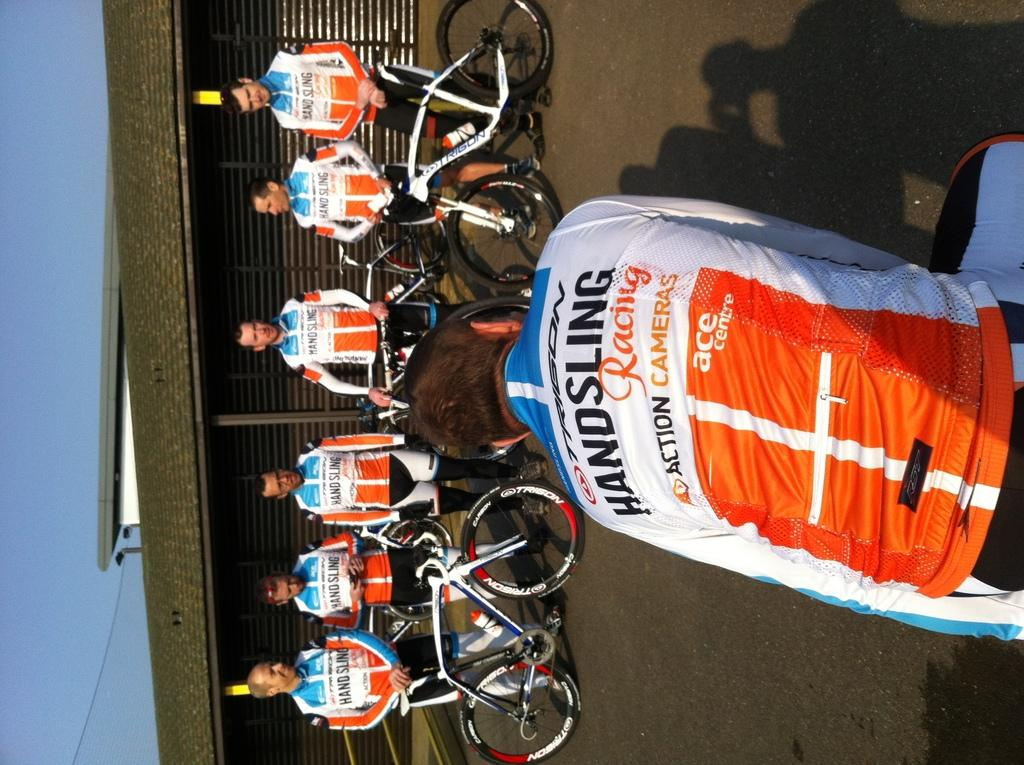What can be seen in the foreground of the image? There are bicycles and a group of people on the road in the foreground of the image. What is visible in the background of the image? There are buildings and the sky in the background of the image. Can you describe the time of day when the image was likely taken? The image was likely taken during the day, as the sky is visible and there is no indication of darkness. What type of wax is being used to create the cakes in the image? There are no cakes or wax present in the image; it features bicycles, a group of people, buildings, and the sky. 